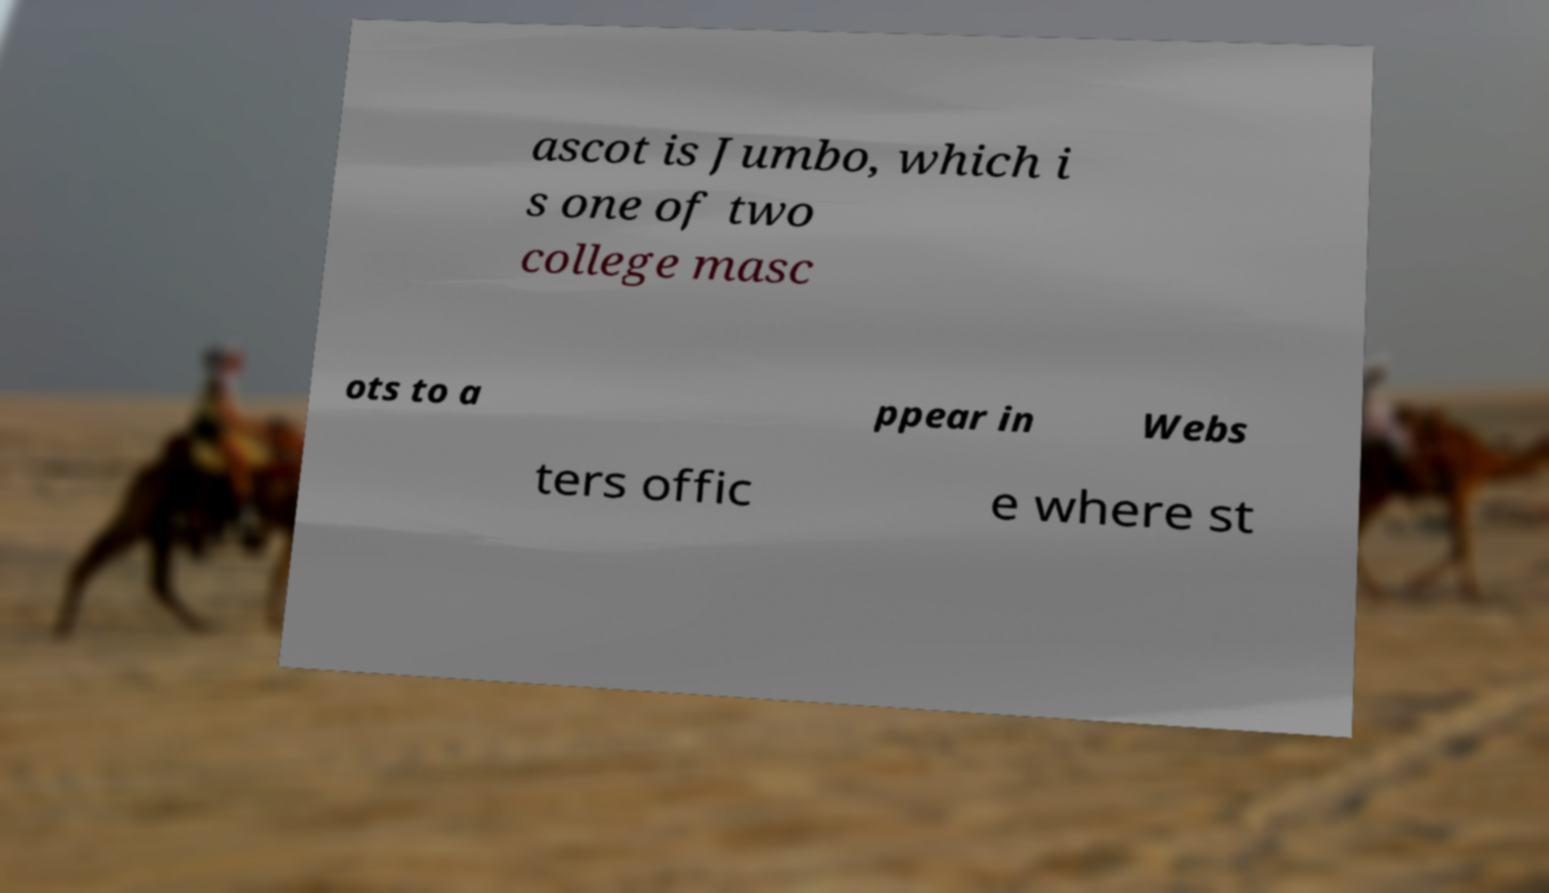Could you assist in decoding the text presented in this image and type it out clearly? ascot is Jumbo, which i s one of two college masc ots to a ppear in Webs ters offic e where st 